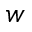Convert formula to latex. <formula><loc_0><loc_0><loc_500><loc_500>w</formula> 